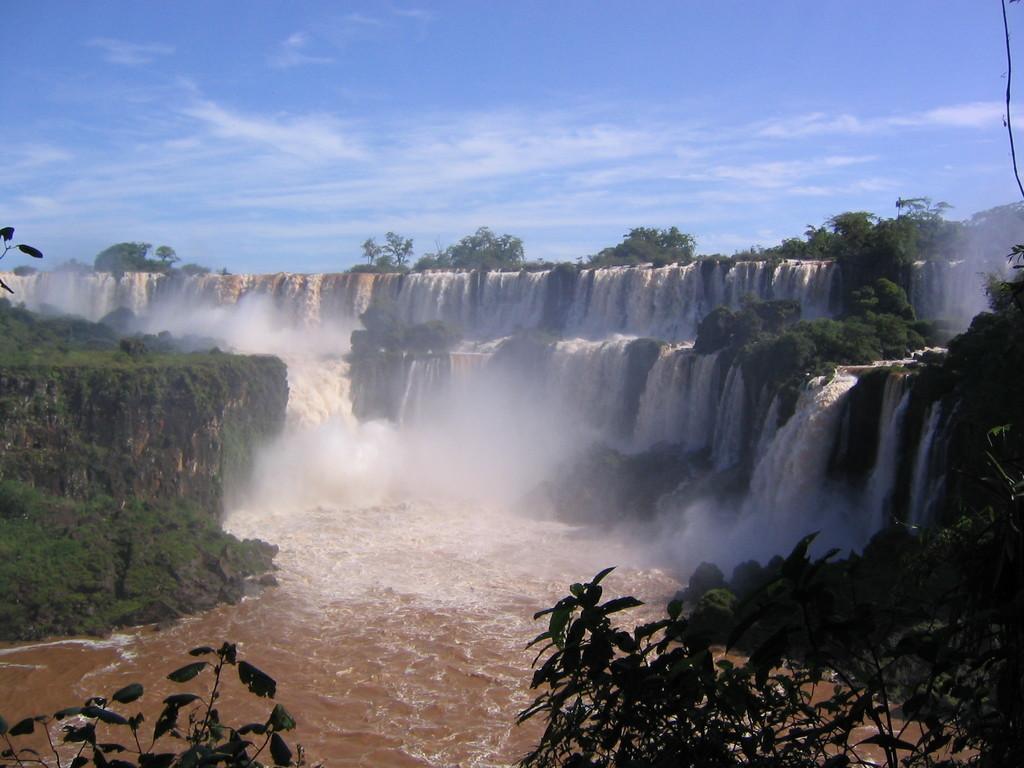In one or two sentences, can you explain what this image depicts? In this picture we can see a few plants on the right side and left side. We can see a waterfall. There are few trees in the background. Sky is blue in color and cloudy. 